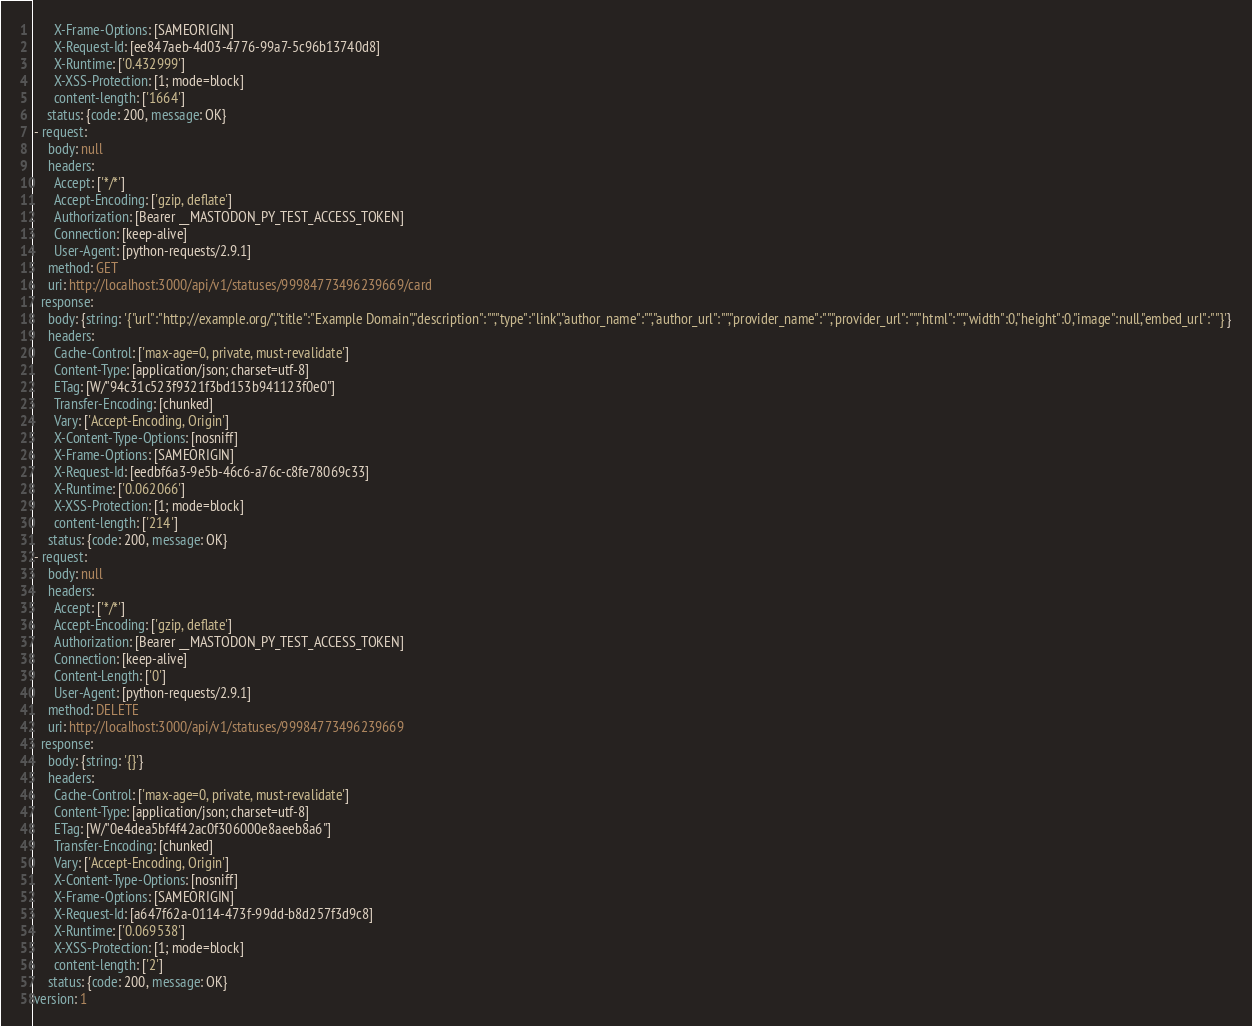<code> <loc_0><loc_0><loc_500><loc_500><_YAML_>      X-Frame-Options: [SAMEORIGIN]
      X-Request-Id: [ee847aeb-4d03-4776-99a7-5c96b13740d8]
      X-Runtime: ['0.432999']
      X-XSS-Protection: [1; mode=block]
      content-length: ['1664']
    status: {code: 200, message: OK}
- request:
    body: null
    headers:
      Accept: ['*/*']
      Accept-Encoding: ['gzip, deflate']
      Authorization: [Bearer __MASTODON_PY_TEST_ACCESS_TOKEN]
      Connection: [keep-alive]
      User-Agent: [python-requests/2.9.1]
    method: GET
    uri: http://localhost:3000/api/v1/statuses/99984773496239669/card
  response:
    body: {string: '{"url":"http://example.org/","title":"Example Domain","description":"","type":"link","author_name":"","author_url":"","provider_name":"","provider_url":"","html":"","width":0,"height":0,"image":null,"embed_url":""}'}
    headers:
      Cache-Control: ['max-age=0, private, must-revalidate']
      Content-Type: [application/json; charset=utf-8]
      ETag: [W/"94c31c523f9321f3bd153b941123f0e0"]
      Transfer-Encoding: [chunked]
      Vary: ['Accept-Encoding, Origin']
      X-Content-Type-Options: [nosniff]
      X-Frame-Options: [SAMEORIGIN]
      X-Request-Id: [eedbf6a3-9e5b-46c6-a76c-c8fe78069c33]
      X-Runtime: ['0.062066']
      X-XSS-Protection: [1; mode=block]
      content-length: ['214']
    status: {code: 200, message: OK}
- request:
    body: null
    headers:
      Accept: ['*/*']
      Accept-Encoding: ['gzip, deflate']
      Authorization: [Bearer __MASTODON_PY_TEST_ACCESS_TOKEN]
      Connection: [keep-alive]
      Content-Length: ['0']
      User-Agent: [python-requests/2.9.1]
    method: DELETE
    uri: http://localhost:3000/api/v1/statuses/99984773496239669
  response:
    body: {string: '{}'}
    headers:
      Cache-Control: ['max-age=0, private, must-revalidate']
      Content-Type: [application/json; charset=utf-8]
      ETag: [W/"0e4dea5bf4f42ac0f306000e8aeeb8a6"]
      Transfer-Encoding: [chunked]
      Vary: ['Accept-Encoding, Origin']
      X-Content-Type-Options: [nosniff]
      X-Frame-Options: [SAMEORIGIN]
      X-Request-Id: [a647f62a-0114-473f-99dd-b8d257f3d9c8]
      X-Runtime: ['0.069538']
      X-XSS-Protection: [1; mode=block]
      content-length: ['2']
    status: {code: 200, message: OK}
version: 1
</code> 